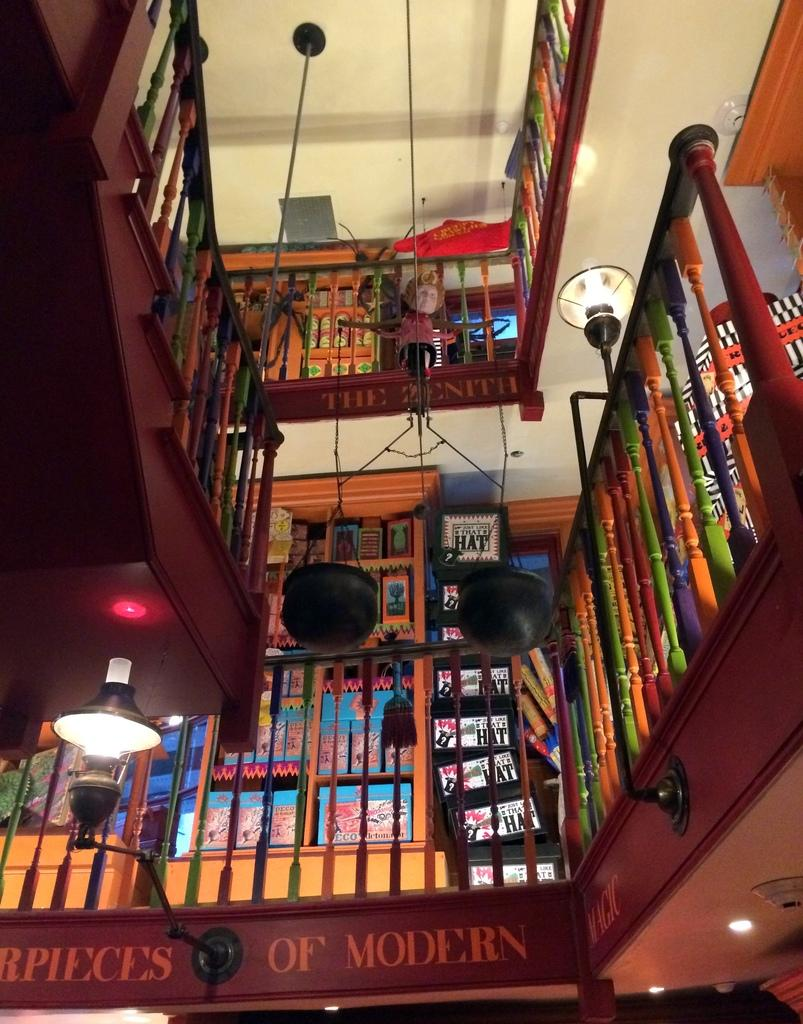<image>
Share a concise interpretation of the image provided. The word modern is on one of the floors next to the light. 